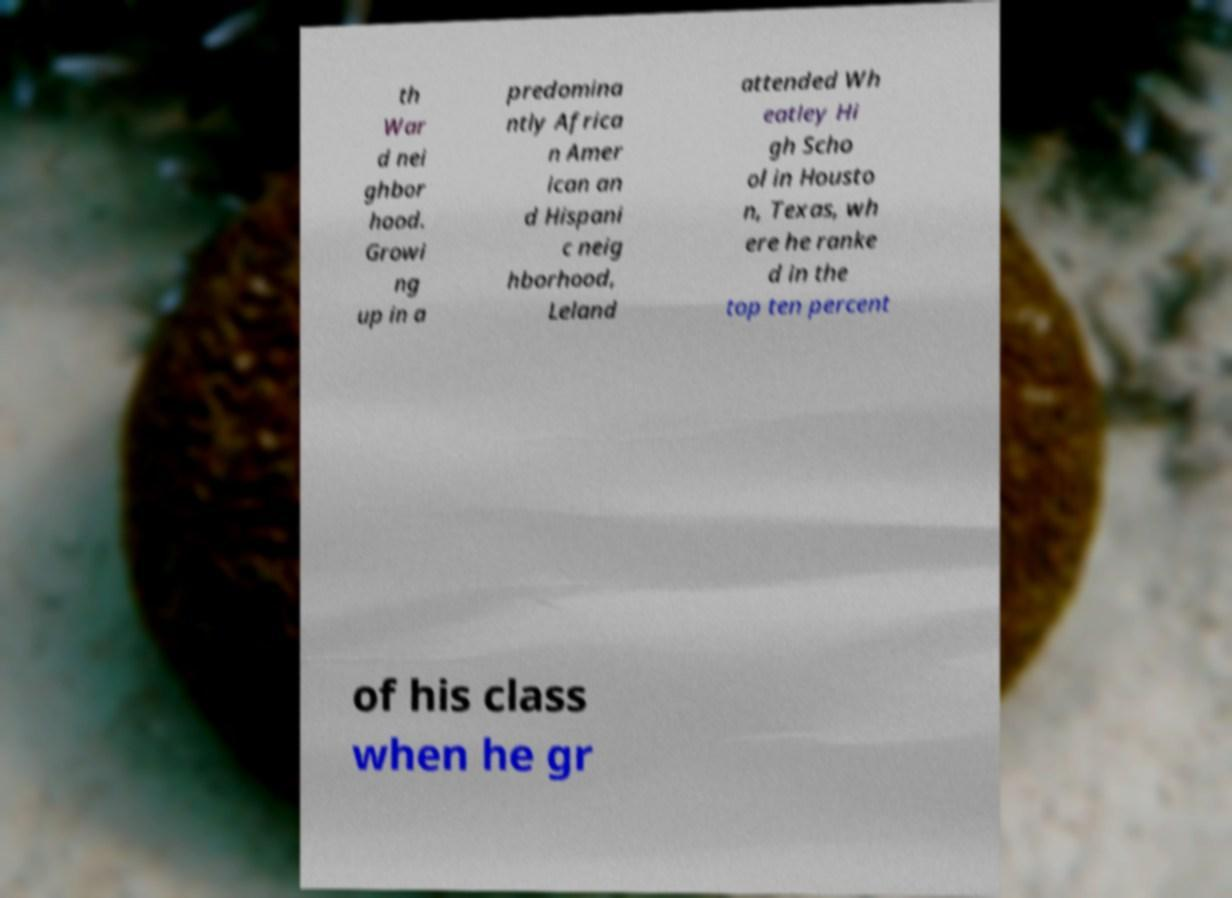There's text embedded in this image that I need extracted. Can you transcribe it verbatim? th War d nei ghbor hood. Growi ng up in a predomina ntly Africa n Amer ican an d Hispani c neig hborhood, Leland attended Wh eatley Hi gh Scho ol in Housto n, Texas, wh ere he ranke d in the top ten percent of his class when he gr 